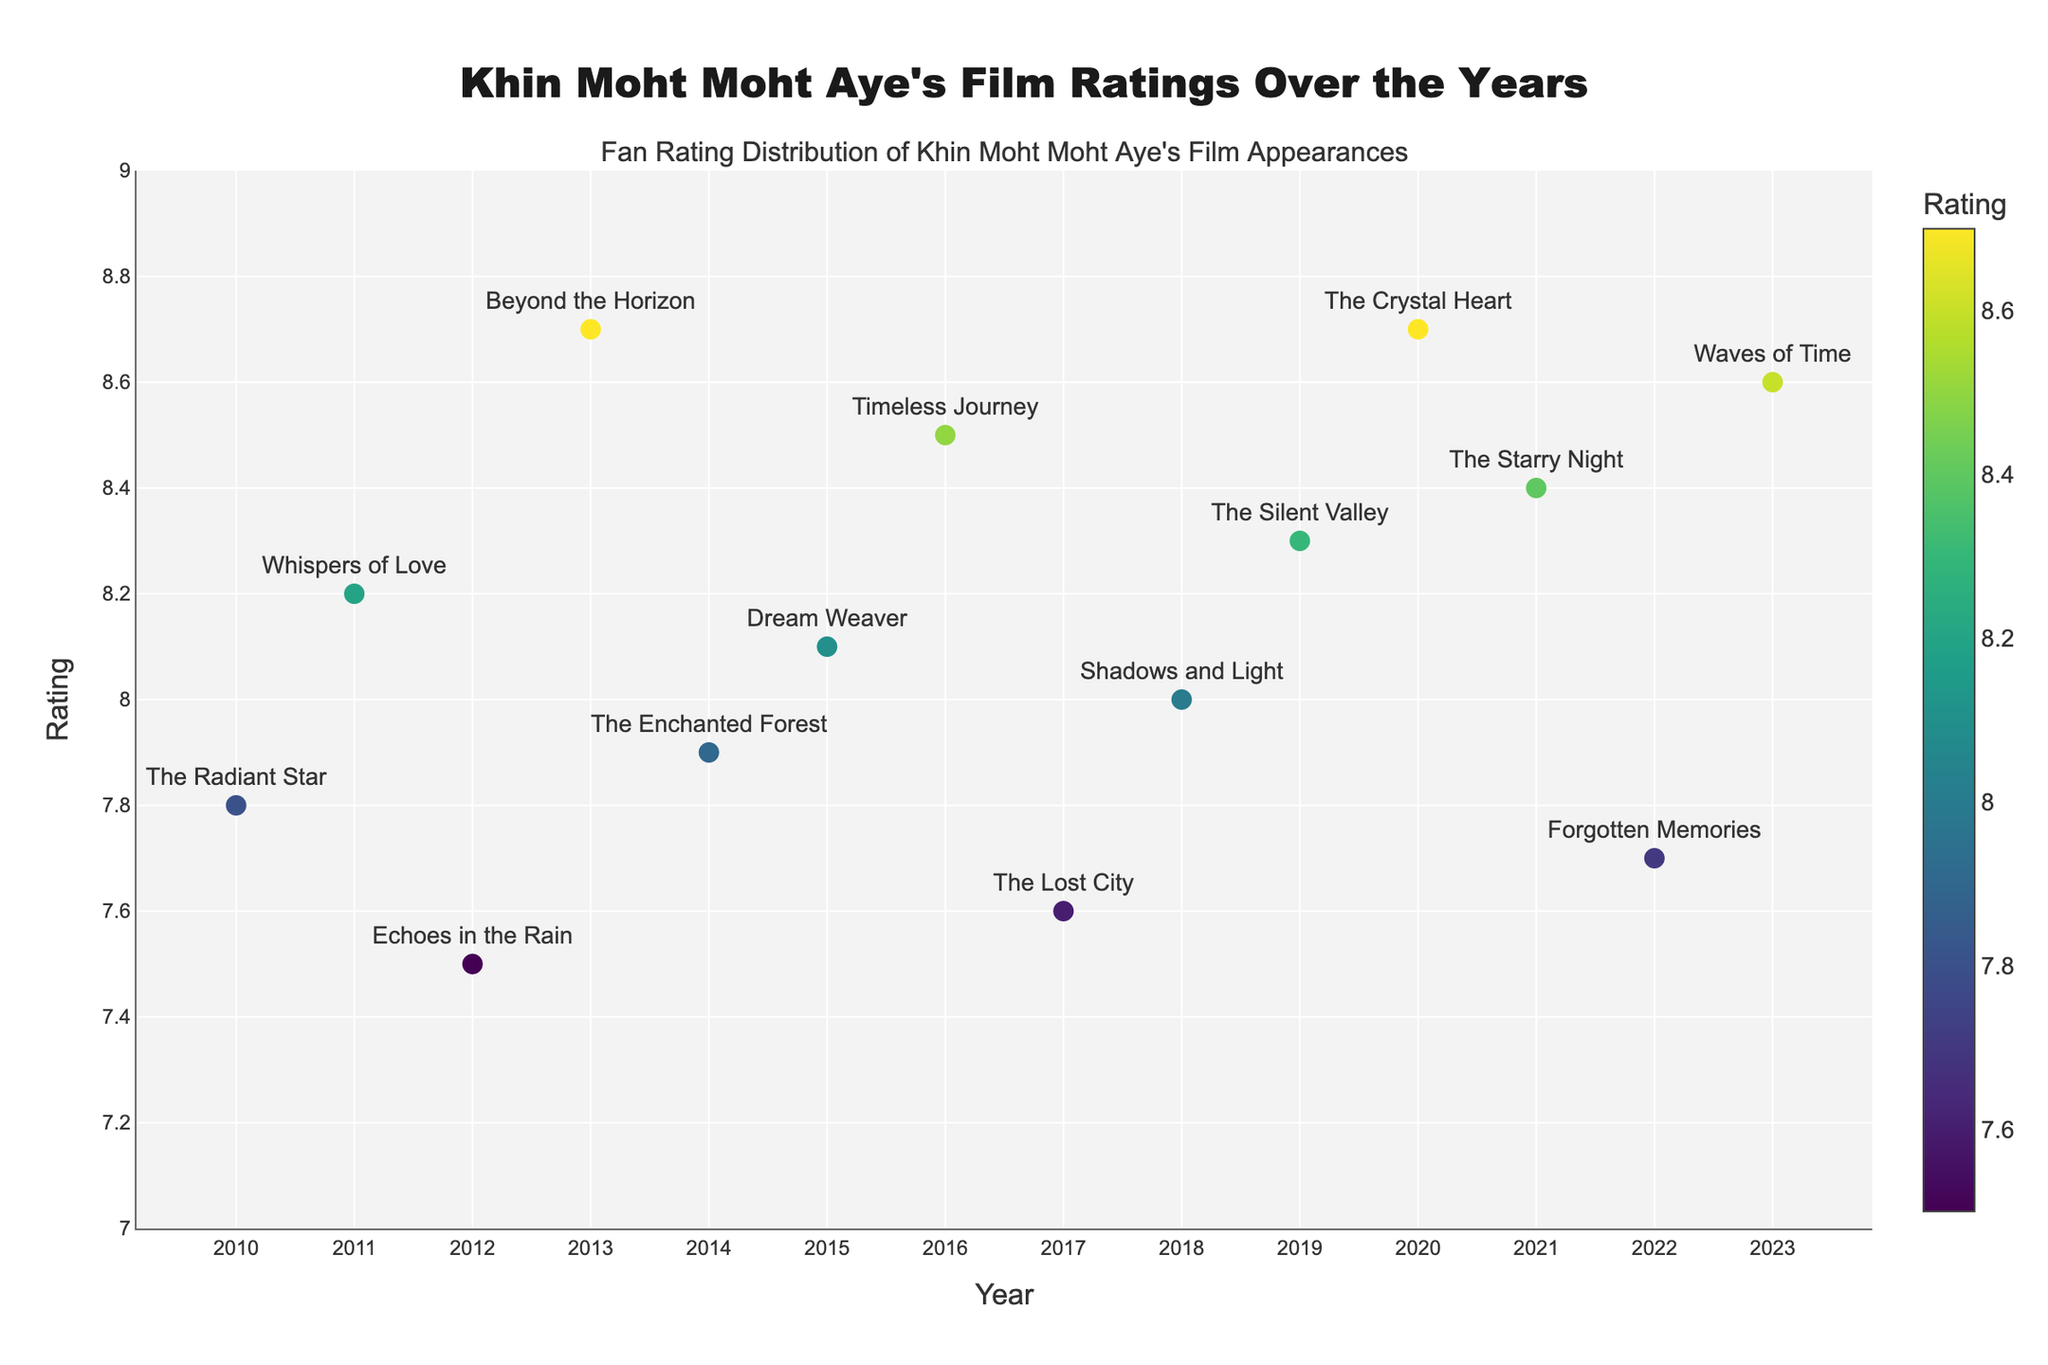What's the title of the plot? The title is usually displayed at the top center of the plot. For this figure, it is specifically set in the code.
Answer: "Khin Moht Moht Aye's Film Ratings Over the Years" What are the ranges for the y-axis on the plot? The y-axis range is set in the code from 7 to 9. This range is visible in the plot's y-axis markings.
Answer: 7 to 9 How many films rated 8.5 or higher are there? Look for data points with ratings 8.5 or higher and count them. The films are "Beyond the Horizon," "Timeless Journey," "The Crystal Heart," "The Starry Night," and "Waves of Time."
Answer: 5 Which film has the lowest rating and what is its rating? Find the data point with the lowest y-coordinate (rating). In the plot, it is "Echoes in the Rain" from 2012 with a rating of 7.5.
Answer: "Echoes in the Rain" - 7.5 What is the average rating for Khin Moht Moht Aye's films from 2010 to 2023? Sum all the ratings and divide by the number of films. The sum of the ratings is 113.0 and there are 14 films. 113.0 / 14 ≈ 8.1
Answer: 8.1 Which film in 2020 has the same rating as any other film? Look for another film with a rating of 8.7, which is the rating for 2020's "The Crystal Heart." "Beyond the Horizon" from 2013 also has a rating of 8.7.
Answer: "Beyond the Horizon" Which year has the highest-rated film and what is the rating? Identify the highest y-coordinate (rating). It corresponds to the films "Beyond the Horizon" (2013) and "The Crystal Heart" (2020), both rated 8.7.
Answer: 2013 and 2020 - 8.7 What is the overall trend of film ratings from 2010 to 2023? Observe the general direction in the scatter plot. The film ratings fluctuate but generally stay in the range of 7.5 to 8.7 without a clear upward or downward trend.
Answer: Fluctuating within 7.5 to 8.7 How many films have ratings between 8.0 and 8.4 (inclusive)? Count the data points with y-values (ratings) in this range: "Whispers of Love" (2011), "Dream Weaver" (2015), "The Silent Valley" (2019), "The Starry Night" (2021), and "Shadows and Light" (2018). There are 5 films.
Answer: 5 